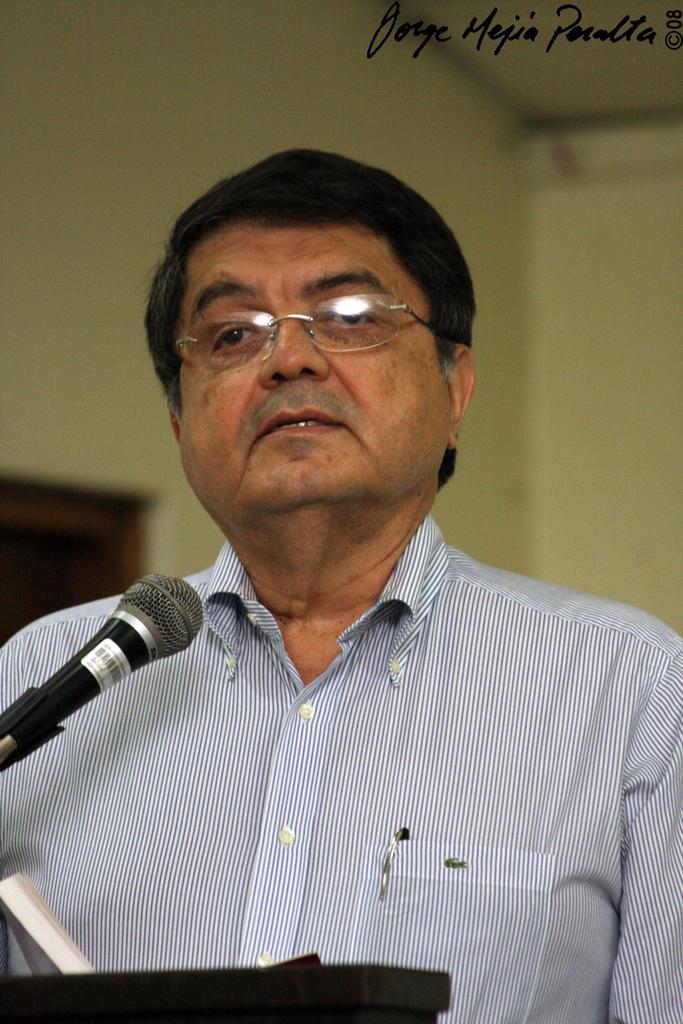Describe this image in one or two sentences. In this image, I can see the man standing. This is the mike. The background looks blurry. At the bottom of the image, I think this is an object. At the top right corner of the image, I can see the watermark. 